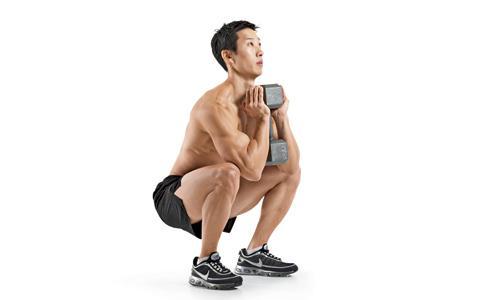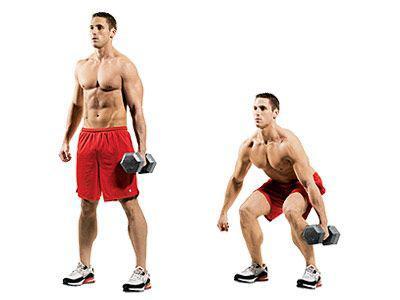The first image is the image on the left, the second image is the image on the right. For the images displayed, is the sentence "The left and right image contains the same number of  people working out with weights." factually correct? Answer yes or no. No. The first image is the image on the left, the second image is the image on the right. Considering the images on both sides, is "Each image shows two steps of a weight workout, with a standing pose on the left and a crouched pose next to it." valid? Answer yes or no. No. 